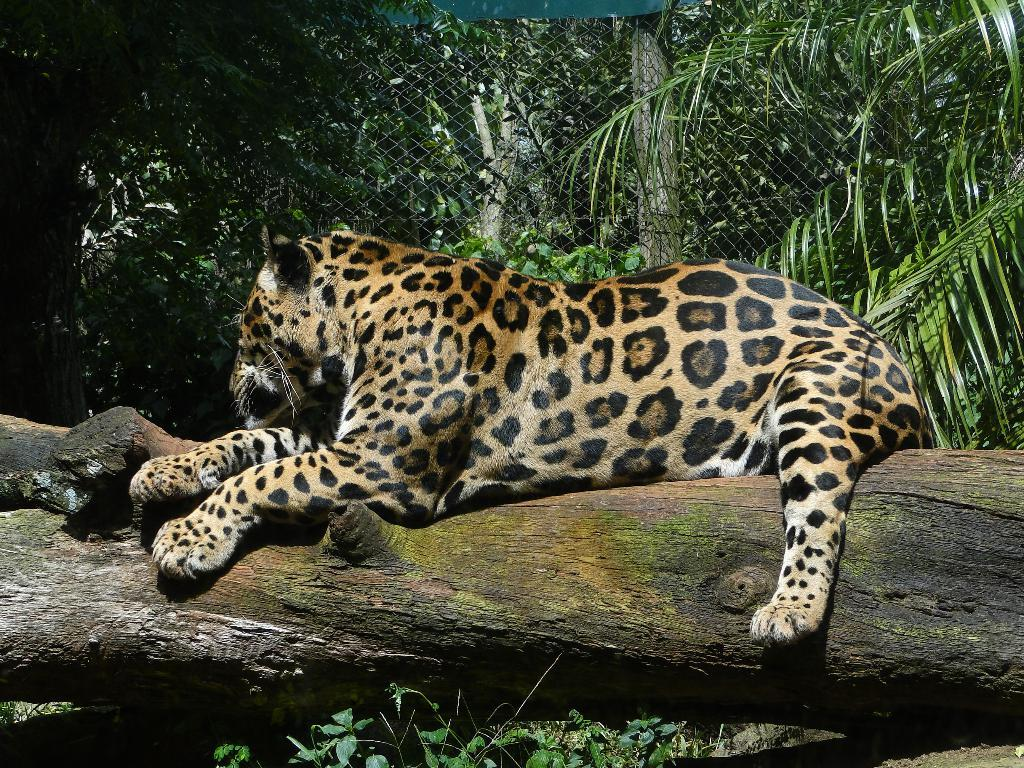What type of vegetation can be seen in the image? There are trees in the image. What type of barrier is present in the image? There is a metal fence in the image. What animal can be seen on the tree bark? A leopard is present on the tree bark. What type of table is visible in the image? There is no table present in the image. Is there a minister in the image? There is no minister present in the image. 